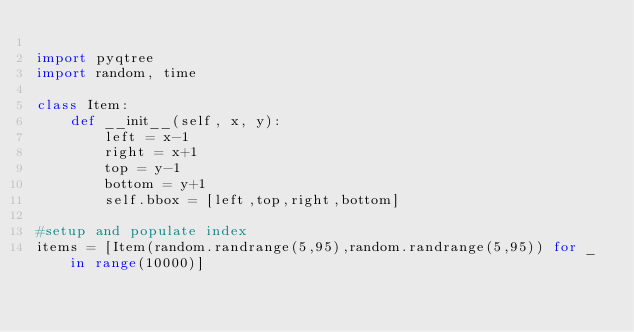Convert code to text. <code><loc_0><loc_0><loc_500><loc_500><_Python_>
import pyqtree
import random, time

class Item:
    def __init__(self, x, y):
        left = x-1
        right = x+1
        top = y-1
        bottom = y+1
        self.bbox = [left,top,right,bottom]

#setup and populate index
items = [Item(random.randrange(5,95),random.randrange(5,95)) for _ in range(10000)]</code> 